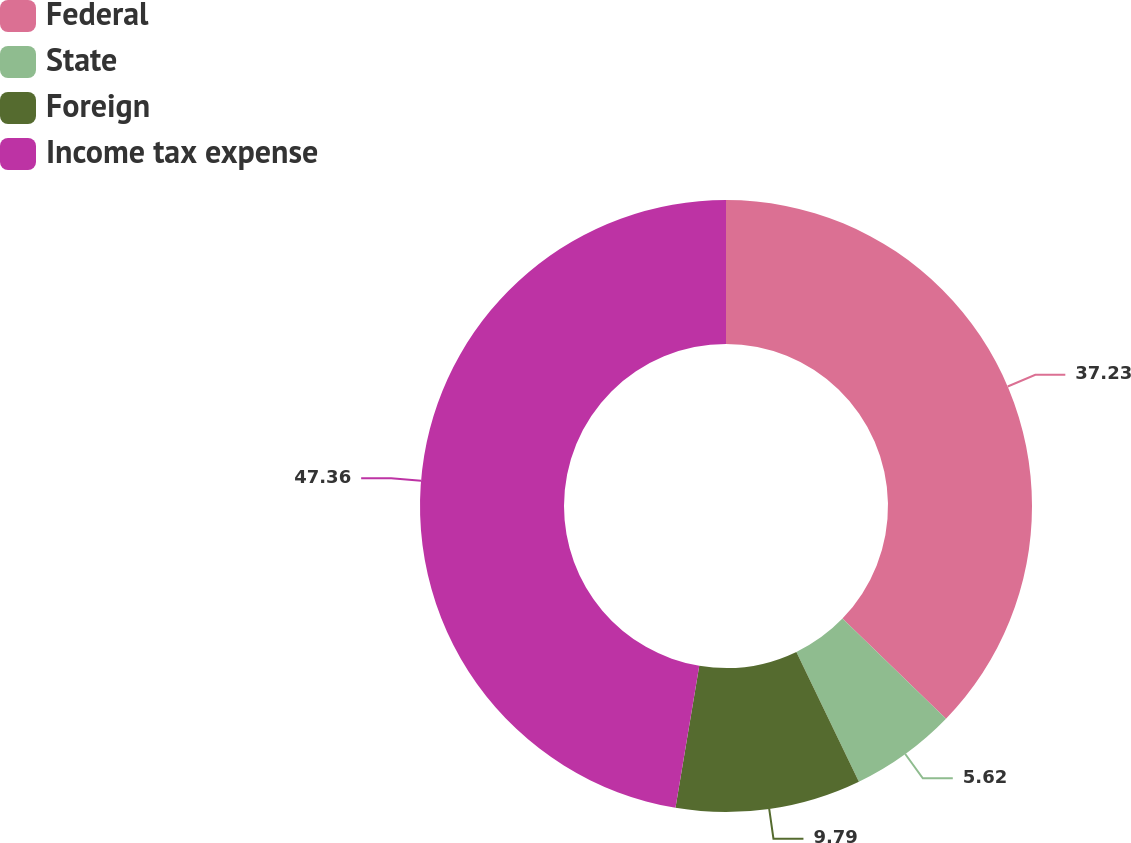Convert chart to OTSL. <chart><loc_0><loc_0><loc_500><loc_500><pie_chart><fcel>Federal<fcel>State<fcel>Foreign<fcel>Income tax expense<nl><fcel>37.23%<fcel>5.62%<fcel>9.79%<fcel>47.36%<nl></chart> 